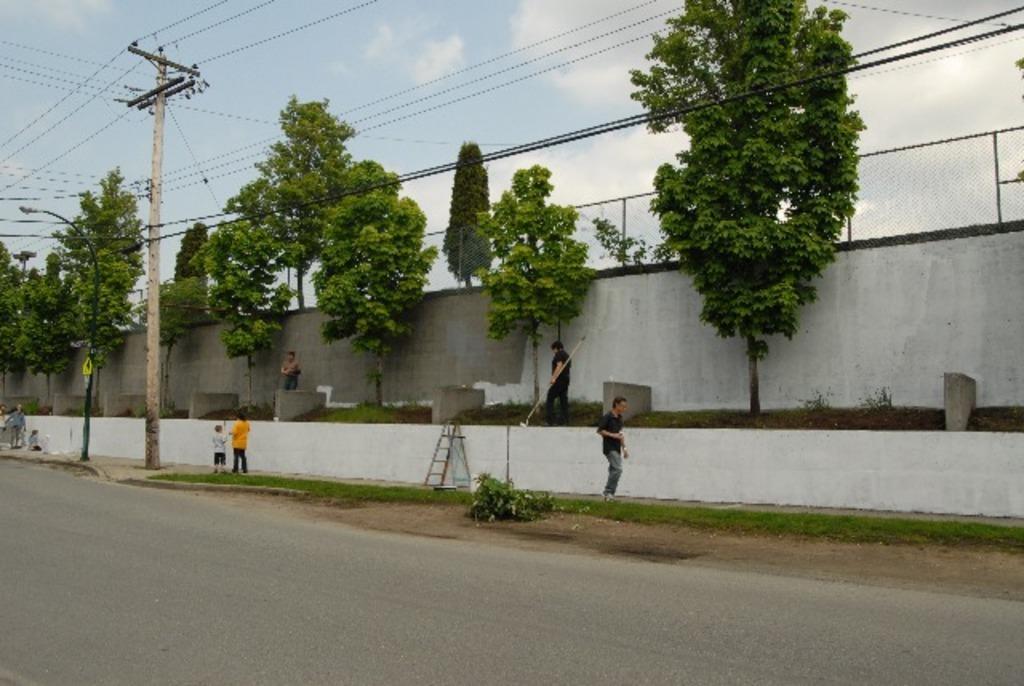Please provide a concise description of this image. In this picture we can see the trees, wall, mesh, wires, poles, light, ladder, board and some persons. At the top of the image we can see the clouds are present in the sky. At the bottom of the image we can see the road. In the middle of the image we can see the plants and grass. 